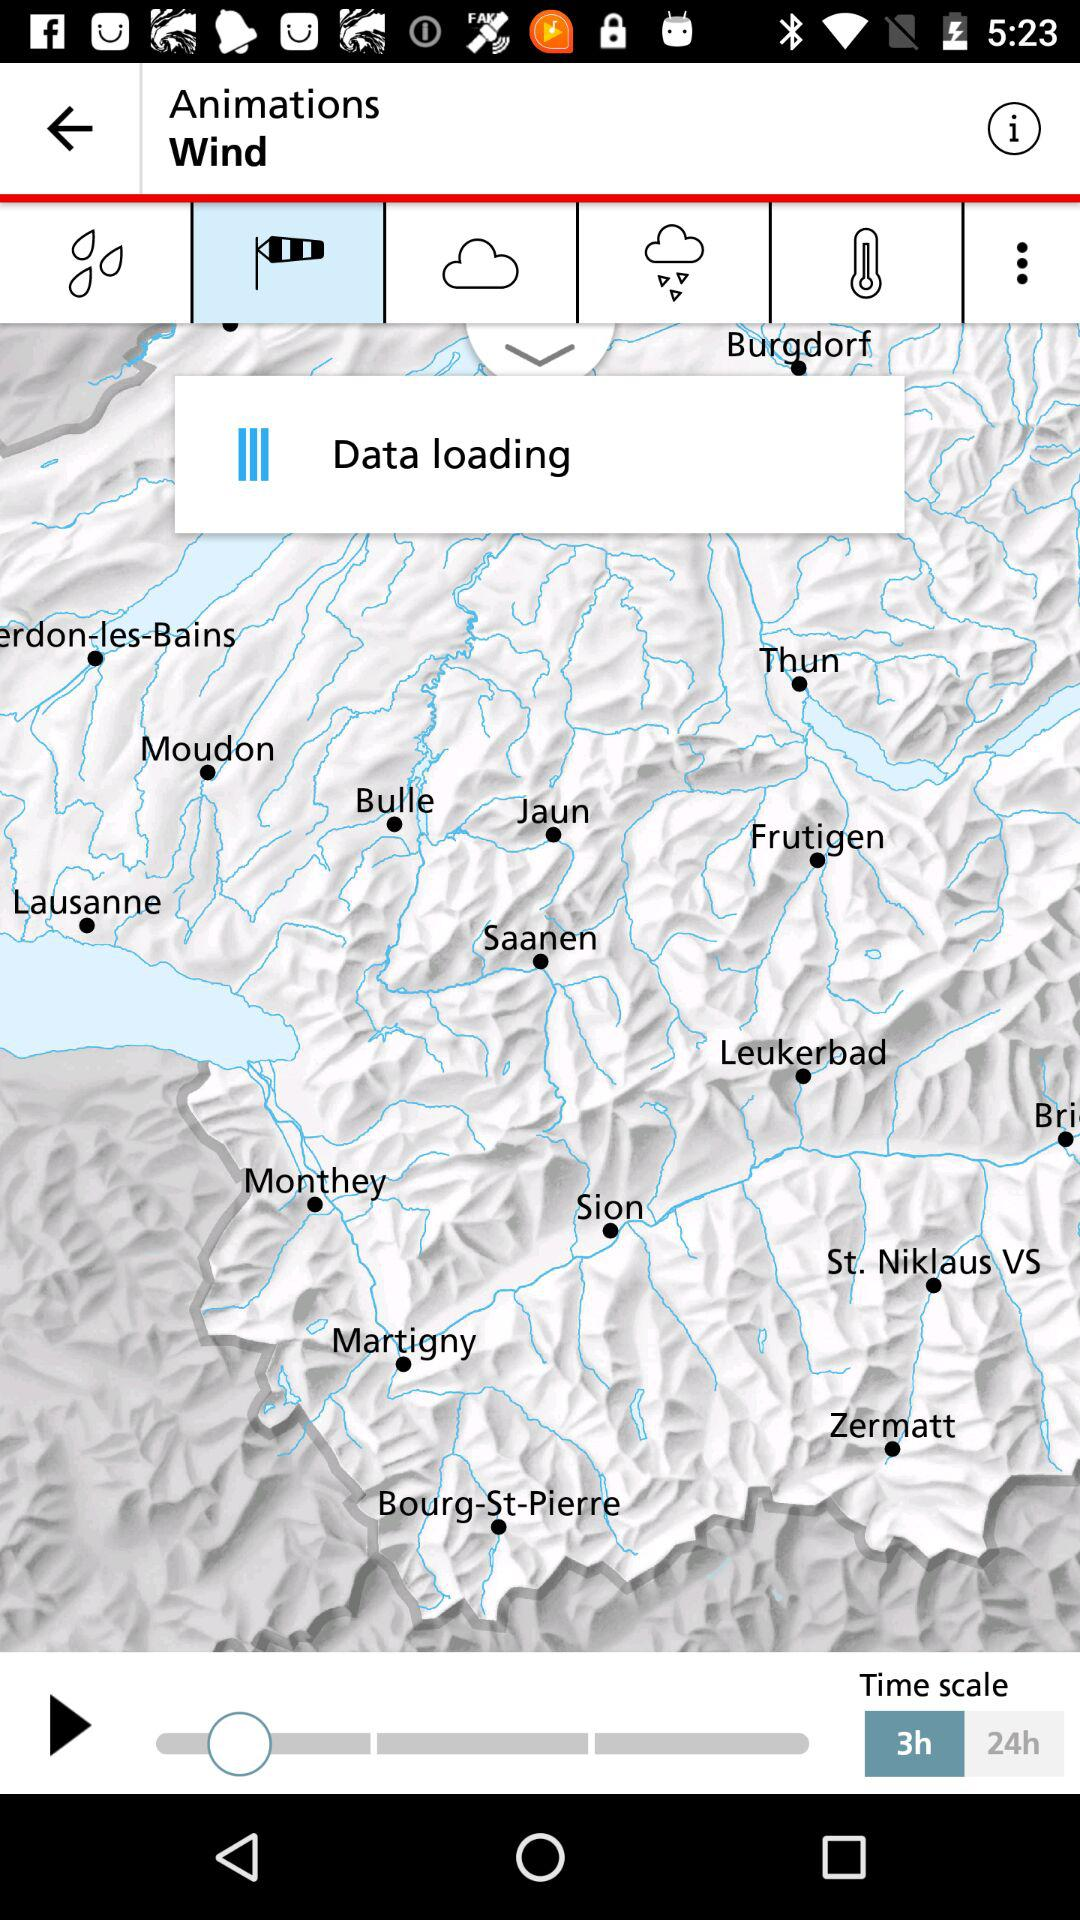What is the selected time scale? The selected time scale is "3h". 